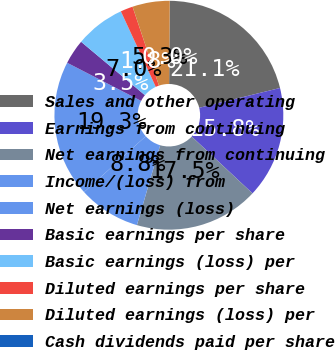Convert chart. <chart><loc_0><loc_0><loc_500><loc_500><pie_chart><fcel>Sales and other operating<fcel>Earnings from continuing<fcel>Net earnings from continuing<fcel>Income/(loss) from<fcel>Net earnings (loss)<fcel>Basic earnings per share<fcel>Basic earnings (loss) per<fcel>Diluted earnings per share<fcel>Diluted earnings (loss) per<fcel>Cash dividends paid per share<nl><fcel>21.05%<fcel>15.79%<fcel>17.54%<fcel>8.77%<fcel>19.3%<fcel>3.51%<fcel>7.02%<fcel>1.75%<fcel>5.26%<fcel>0.0%<nl></chart> 